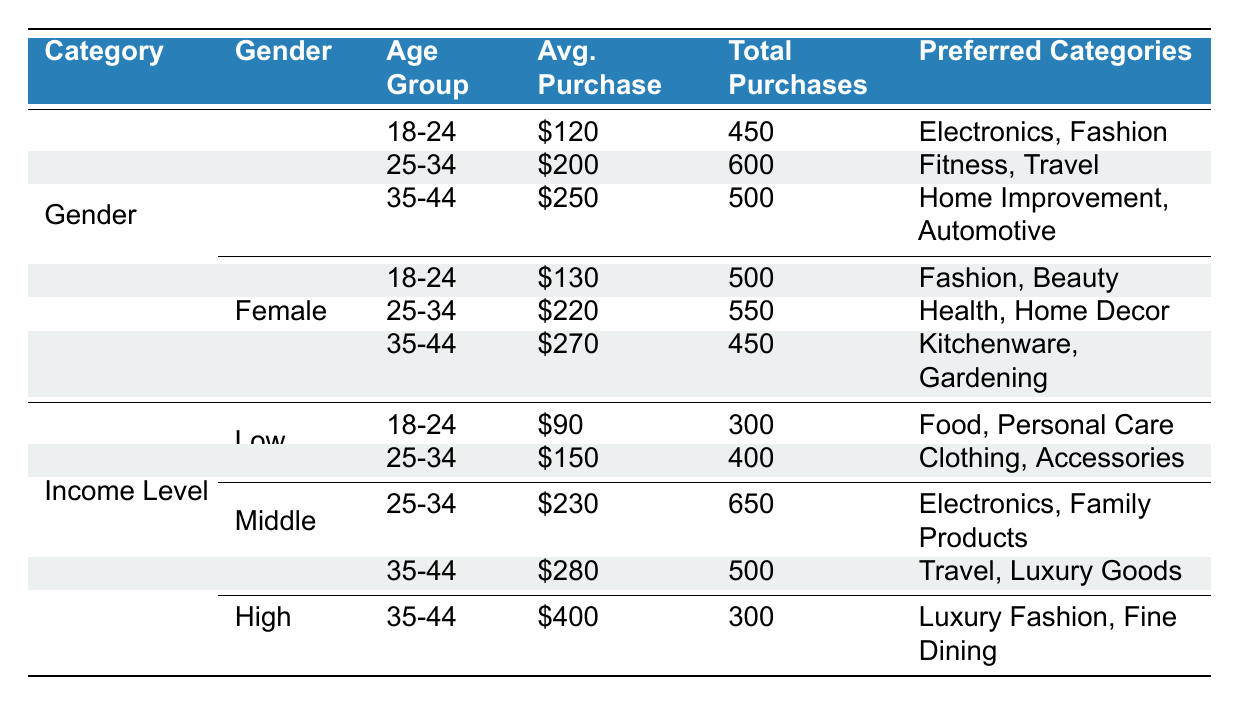What is the average purchase amount for males in the age group 25-34? From the table, the average purchase amount for males in the age group 25-34 is listed as 200.
Answer: 200 How many total purchases did females aged 18-24 make? The table indicates that females aged 18-24 made a total of 500 purchases.
Answer: 500 Which age group has the highest average purchase amount among females? By comparing the average purchase amounts for the female age groups, 35-44 has the highest average at 270.
Answer: 35-44 Is the average purchase amount for males in the age group 35-44 greater than 250? Checking the data, the average purchase amount for males aged 35-44 is indeed 250, so it is not greater than.
Answer: No What is the total number of purchases made by low-income customers in the age group 25-34? According to the table, low-income customers in the age group 25-34 made a total of 400 purchases.
Answer: 400 Calculate the difference between the average purchase amounts of middle-income customers aged 25-34 and low-income customers aged 25-34. The average purchase amount for middle-income customers aged 25-34 is 230, while for low-income customers, it’s 150. The difference is 230 - 150 = 80.
Answer: 80 Which demographic category made the most total purchases based on the table? To find the demographic with the most total purchases, we add purchases across the rows: males total 450 + 600 + 500 = 1550 and females total 500 + 550 + 450 = 1500, so males made the most.
Answer: Males What are the preferred categories for high-income customers aged 35-44? The table shows that high-income customers in the 35-44 age group prefer categories such as Luxury Fashion and Fine Dining.
Answer: Luxury Fashion, Fine Dining Do middle-income customers have any recorded purchases for the age group 18-24? The table displays that middle-income customers do not have any purchases recorded for the age group 18-24.
Answer: No 